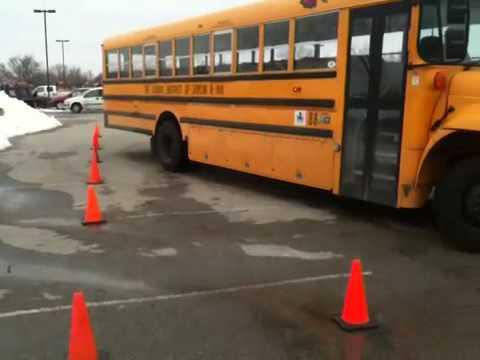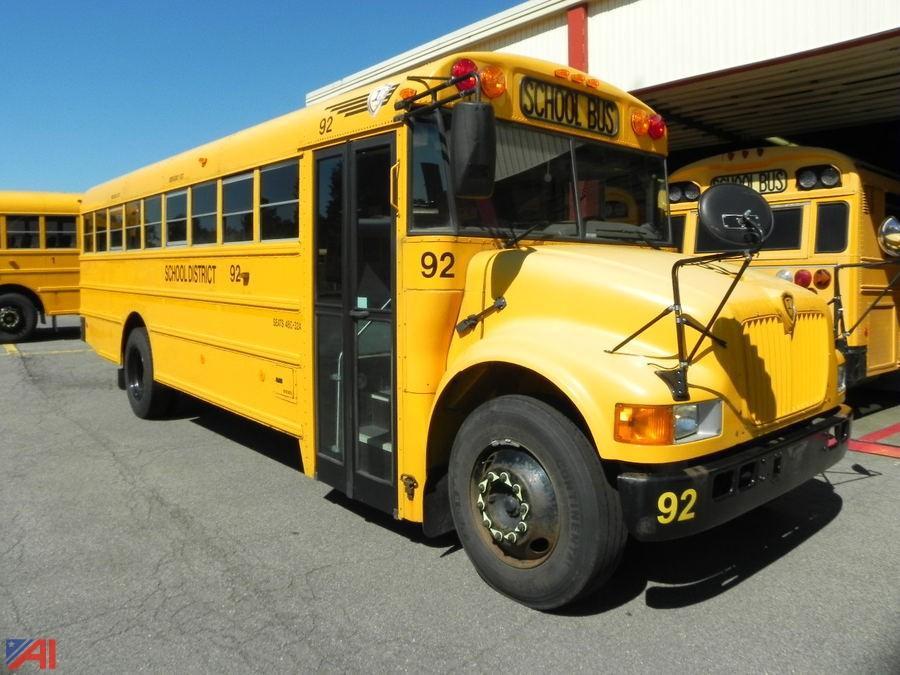The first image is the image on the left, the second image is the image on the right. Assess this claim about the two images: "All the buses are stopped or parked within close proximity to trees.". Correct or not? Answer yes or no. No. The first image is the image on the left, the second image is the image on the right. Examine the images to the left and right. Is the description "There is a school bus that will need immediate repair." accurate? Answer yes or no. No. 